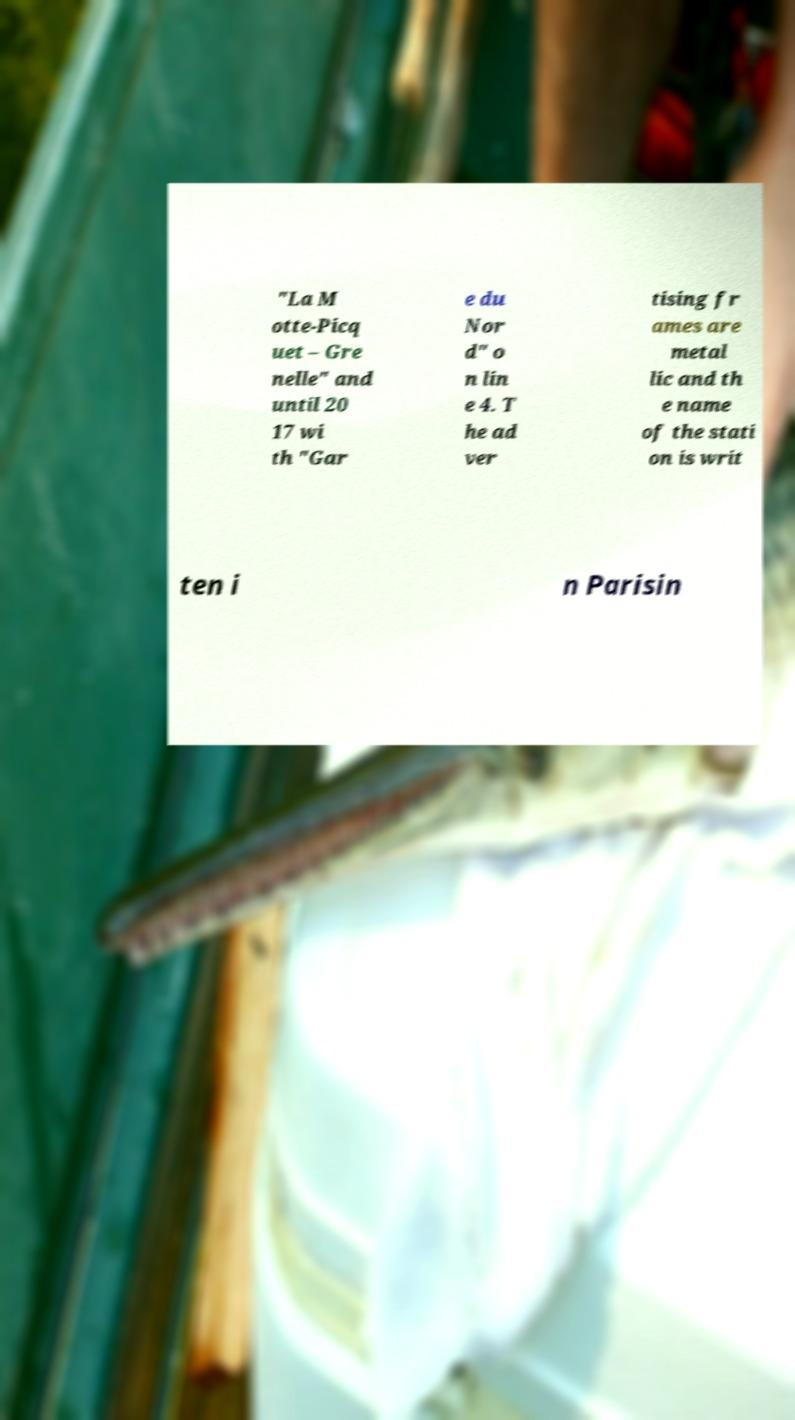Could you assist in decoding the text presented in this image and type it out clearly? "La M otte-Picq uet – Gre nelle" and until 20 17 wi th "Gar e du Nor d" o n lin e 4. T he ad ver tising fr ames are metal lic and th e name of the stati on is writ ten i n Parisin 